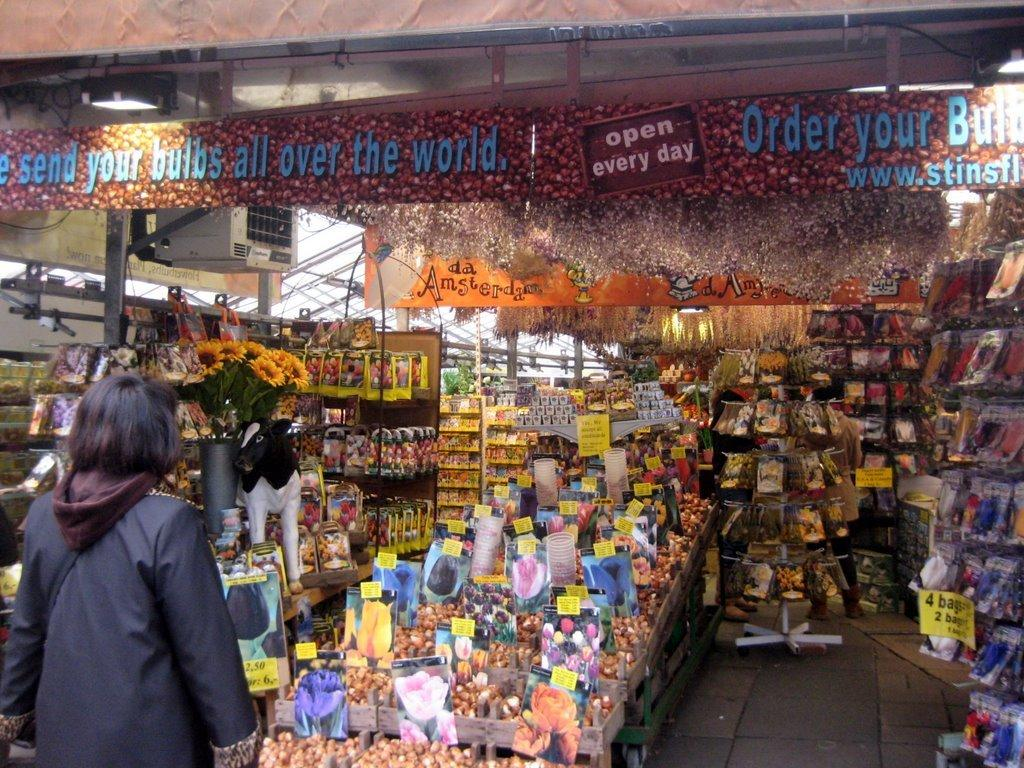<image>
Give a short and clear explanation of the subsequent image. A store of some kind with a sign overhead that says open every day 